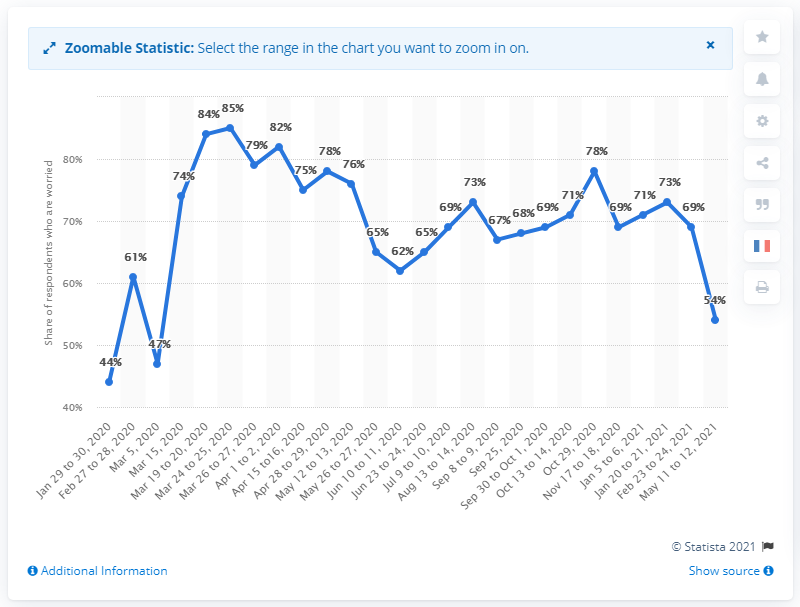Identify some key points in this picture. A survey conducted in March 2020 revealed that 85% of French people were concerned about the spread of the COVID-19 virus. 